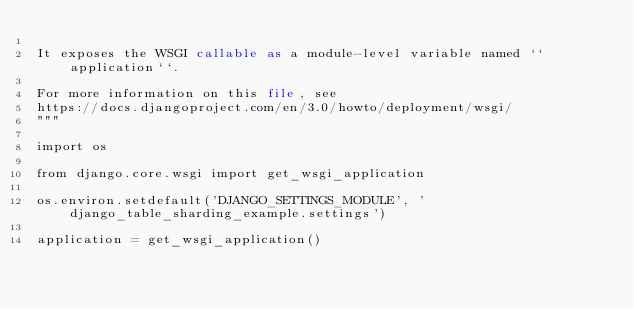<code> <loc_0><loc_0><loc_500><loc_500><_Python_>
It exposes the WSGI callable as a module-level variable named ``application``.

For more information on this file, see
https://docs.djangoproject.com/en/3.0/howto/deployment/wsgi/
"""

import os

from django.core.wsgi import get_wsgi_application

os.environ.setdefault('DJANGO_SETTINGS_MODULE', 'django_table_sharding_example.settings')

application = get_wsgi_application()
</code> 